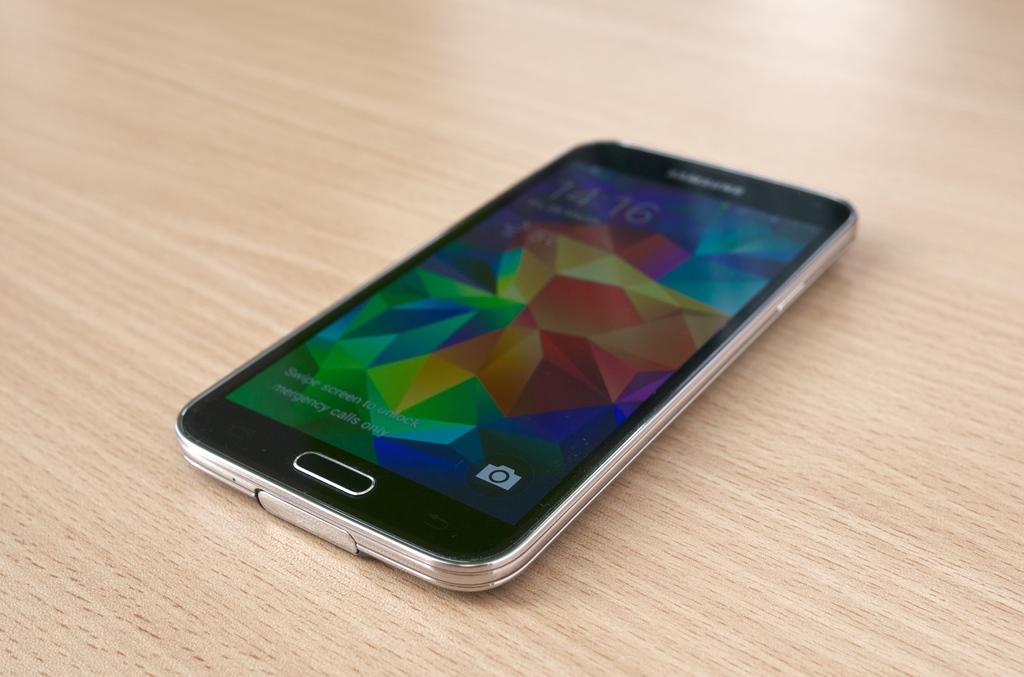What time does the phone show?
Keep it short and to the point. 14:16. 